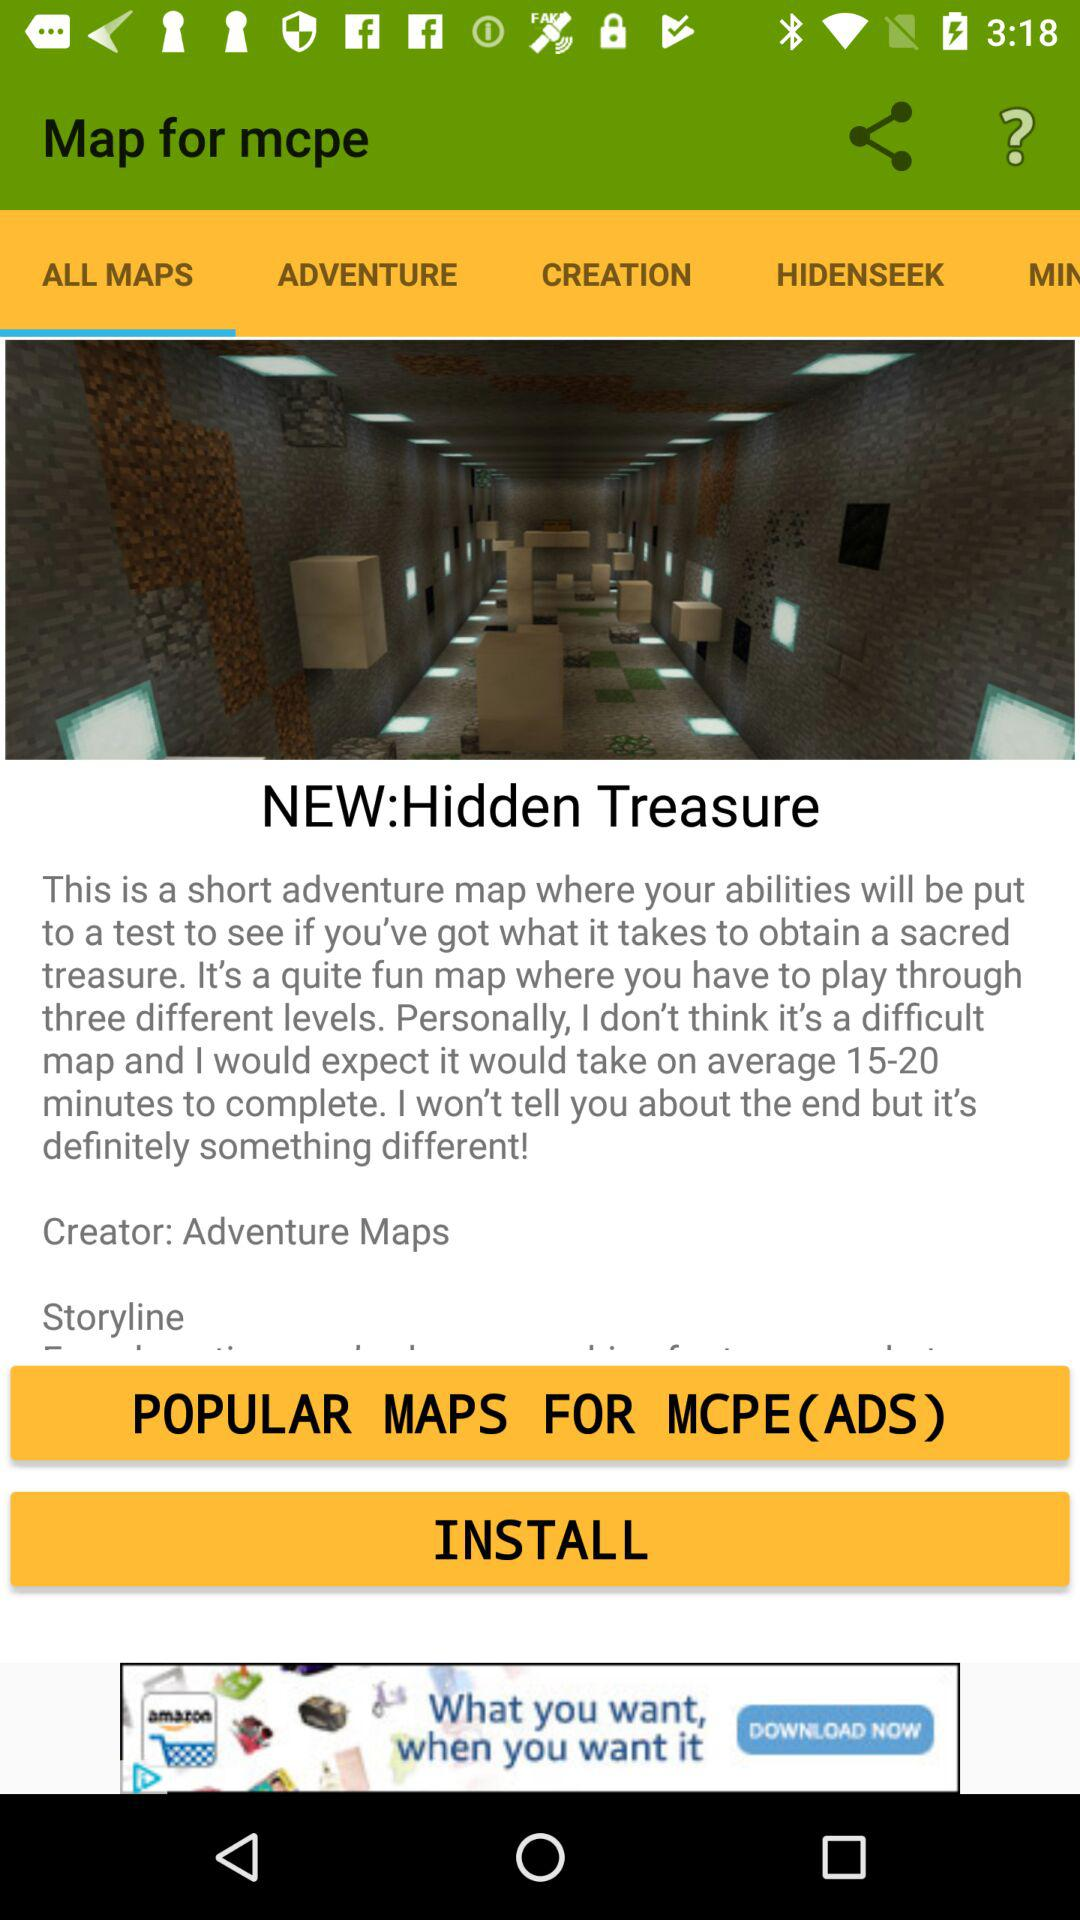How long does it take to complete the map?
Answer the question using a single word or phrase. 15-20 minutes 